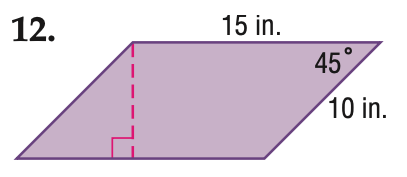Question: Find the perimeter of the parallelogram. Round to the nearest tenth if necessary.
Choices:
A. 25
B. 30
C. 40
D. 50
Answer with the letter. Answer: D Question: Find the area of the parallelogram. Round to the nearest tenth if necessary.
Choices:
A. 75
B. 106.1
C. 150
D. 212.1
Answer with the letter. Answer: B 